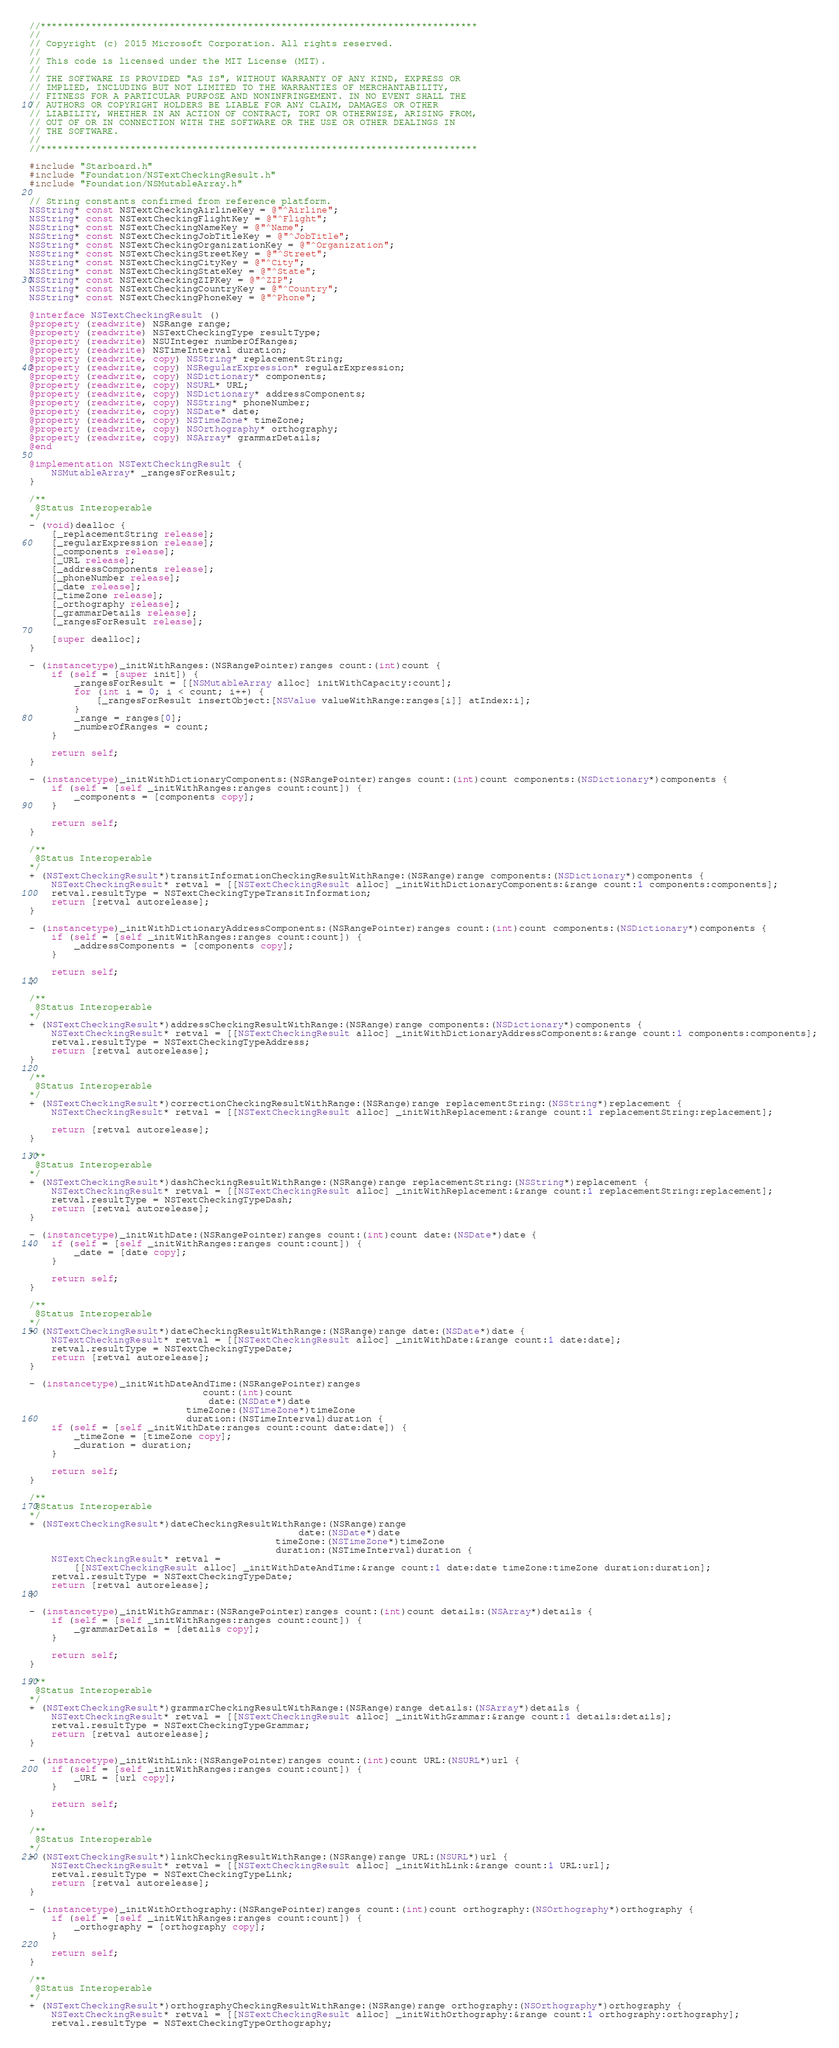<code> <loc_0><loc_0><loc_500><loc_500><_ObjectiveC_>//******************************************************************************
//
// Copyright (c) 2015 Microsoft Corporation. All rights reserved.
//
// This code is licensed under the MIT License (MIT).
//
// THE SOFTWARE IS PROVIDED "AS IS", WITHOUT WARRANTY OF ANY KIND, EXPRESS OR
// IMPLIED, INCLUDING BUT NOT LIMITED TO THE WARRANTIES OF MERCHANTABILITY,
// FITNESS FOR A PARTICULAR PURPOSE AND NONINFRINGEMENT. IN NO EVENT SHALL THE
// AUTHORS OR COPYRIGHT HOLDERS BE LIABLE FOR ANY CLAIM, DAMAGES OR OTHER
// LIABILITY, WHETHER IN AN ACTION OF CONTRACT, TORT OR OTHERWISE, ARISING FROM,
// OUT OF OR IN CONNECTION WITH THE SOFTWARE OR THE USE OR OTHER DEALINGS IN
// THE SOFTWARE.
//
//******************************************************************************

#include "Starboard.h"
#include "Foundation/NSTextCheckingResult.h"
#include "Foundation/NSMutableArray.h"

// String constants confirmed from reference platform.
NSString* const NSTextCheckingAirlineKey = @"^Airline";
NSString* const NSTextCheckingFlightKey = @"^Flight";
NSString* const NSTextCheckingNameKey = @"^Name";
NSString* const NSTextCheckingJobTitleKey = @"^JobTitle";
NSString* const NSTextCheckingOrganizationKey = @"^Organization";
NSString* const NSTextCheckingStreetKey = @"^Street";
NSString* const NSTextCheckingCityKey = @"^City";
NSString* const NSTextCheckingStateKey = @"^State";
NSString* const NSTextCheckingZIPKey = @"^ZIP";
NSString* const NSTextCheckingCountryKey = @"^Country";
NSString* const NSTextCheckingPhoneKey = @"^Phone";

@interface NSTextCheckingResult ()
@property (readwrite) NSRange range;
@property (readwrite) NSTextCheckingType resultType;
@property (readwrite) NSUInteger numberOfRanges;
@property (readwrite) NSTimeInterval duration;
@property (readwrite, copy) NSString* replacementString;
@property (readwrite, copy) NSRegularExpression* regularExpression;
@property (readwrite, copy) NSDictionary* components;
@property (readwrite, copy) NSURL* URL;
@property (readwrite, copy) NSDictionary* addressComponents;
@property (readwrite, copy) NSString* phoneNumber;
@property (readwrite, copy) NSDate* date;
@property (readwrite, copy) NSTimeZone* timeZone;
@property (readwrite, copy) NSOrthography* orthography;
@property (readwrite, copy) NSArray* grammarDetails;
@end

@implementation NSTextCheckingResult {
    NSMutableArray* _rangesForResult;
}

/**
 @Status Interoperable
*/
- (void)dealloc {
    [_replacementString release];
    [_regularExpression release];
    [_components release];
    [_URL release];
    [_addressComponents release];
    [_phoneNumber release];
    [_date release];
    [_timeZone release];
    [_orthography release];
    [_grammarDetails release];
    [_rangesForResult release];

    [super dealloc];
}

- (instancetype)_initWithRanges:(NSRangePointer)ranges count:(int)count {
    if (self = [super init]) {
        _rangesForResult = [[NSMutableArray alloc] initWithCapacity:count];
        for (int i = 0; i < count; i++) {
            [_rangesForResult insertObject:[NSValue valueWithRange:ranges[i]] atIndex:i];
        }
        _range = ranges[0];
        _numberOfRanges = count;
    }

    return self;
}

- (instancetype)_initWithDictionaryComponents:(NSRangePointer)ranges count:(int)count components:(NSDictionary*)components {
    if (self = [self _initWithRanges:ranges count:count]) {
        _components = [components copy];
    }

    return self;
}

/**
 @Status Interoperable
*/
+ (NSTextCheckingResult*)transitInformationCheckingResultWithRange:(NSRange)range components:(NSDictionary*)components {
    NSTextCheckingResult* retval = [[NSTextCheckingResult alloc] _initWithDictionaryComponents:&range count:1 components:components];
    retval.resultType = NSTextCheckingTypeTransitInformation;
    return [retval autorelease];
}

- (instancetype)_initWithDictionaryAddressComponents:(NSRangePointer)ranges count:(int)count components:(NSDictionary*)components {
    if (self = [self _initWithRanges:ranges count:count]) {
        _addressComponents = [components copy];
    }

    return self;
}

/**
 @Status Interoperable
*/
+ (NSTextCheckingResult*)addressCheckingResultWithRange:(NSRange)range components:(NSDictionary*)components {
    NSTextCheckingResult* retval = [[NSTextCheckingResult alloc] _initWithDictionaryAddressComponents:&range count:1 components:components];
    retval.resultType = NSTextCheckingTypeAddress;
    return [retval autorelease];
}

/**
 @Status Interoperable
*/
+ (NSTextCheckingResult*)correctionCheckingResultWithRange:(NSRange)range replacementString:(NSString*)replacement {
    NSTextCheckingResult* retval = [[NSTextCheckingResult alloc] _initWithReplacement:&range count:1 replacementString:replacement];

    return [retval autorelease];
}

/**
 @Status Interoperable
*/
+ (NSTextCheckingResult*)dashCheckingResultWithRange:(NSRange)range replacementString:(NSString*)replacement {
    NSTextCheckingResult* retval = [[NSTextCheckingResult alloc] _initWithReplacement:&range count:1 replacementString:replacement];
    retval.resultType = NSTextCheckingTypeDash;
    return [retval autorelease];
}

- (instancetype)_initWithDate:(NSRangePointer)ranges count:(int)count date:(NSDate*)date {
    if (self = [self _initWithRanges:ranges count:count]) {
        _date = [date copy];
    }

    return self;
}

/**
 @Status Interoperable
*/
+ (NSTextCheckingResult*)dateCheckingResultWithRange:(NSRange)range date:(NSDate*)date {
    NSTextCheckingResult* retval = [[NSTextCheckingResult alloc] _initWithDate:&range count:1 date:date];
    retval.resultType = NSTextCheckingTypeDate;
    return [retval autorelease];
}

- (instancetype)_initWithDateAndTime:(NSRangePointer)ranges
                               count:(int)count
                                date:(NSDate*)date
                            timeZone:(NSTimeZone*)timeZone
                            duration:(NSTimeInterval)duration {
    if (self = [self _initWithDate:ranges count:count date:date]) {
        _timeZone = [timeZone copy];
        _duration = duration;
    }

    return self;
}

/**
 @Status Interoperable
*/
+ (NSTextCheckingResult*)dateCheckingResultWithRange:(NSRange)range
                                                date:(NSDate*)date
                                            timeZone:(NSTimeZone*)timeZone
                                            duration:(NSTimeInterval)duration {
    NSTextCheckingResult* retval =
        [[NSTextCheckingResult alloc] _initWithDateAndTime:&range count:1 date:date timeZone:timeZone duration:duration];
    retval.resultType = NSTextCheckingTypeDate;
    return [retval autorelease];
}

- (instancetype)_initWithGrammar:(NSRangePointer)ranges count:(int)count details:(NSArray*)details {
    if (self = [self _initWithRanges:ranges count:count]) {
        _grammarDetails = [details copy];
    }

    return self;
}

/**
 @Status Interoperable
*/
+ (NSTextCheckingResult*)grammarCheckingResultWithRange:(NSRange)range details:(NSArray*)details {
    NSTextCheckingResult* retval = [[NSTextCheckingResult alloc] _initWithGrammar:&range count:1 details:details];
    retval.resultType = NSTextCheckingTypeGrammar;
    return [retval autorelease];
}

- (instancetype)_initWithLink:(NSRangePointer)ranges count:(int)count URL:(NSURL*)url {
    if (self = [self _initWithRanges:ranges count:count]) {
        _URL = [url copy];
    }

    return self;
}

/**
 @Status Interoperable
*/
+ (NSTextCheckingResult*)linkCheckingResultWithRange:(NSRange)range URL:(NSURL*)url {
    NSTextCheckingResult* retval = [[NSTextCheckingResult alloc] _initWithLink:&range count:1 URL:url];
    retval.resultType = NSTextCheckingTypeLink;
    return [retval autorelease];
}

- (instancetype)_initWithOrthography:(NSRangePointer)ranges count:(int)count orthography:(NSOrthography*)orthography {
    if (self = [self _initWithRanges:ranges count:count]) {
        _orthography = [orthography copy];
    }

    return self;
}

/**
 @Status Interoperable
*/
+ (NSTextCheckingResult*)orthographyCheckingResultWithRange:(NSRange)range orthography:(NSOrthography*)orthography {
    NSTextCheckingResult* retval = [[NSTextCheckingResult alloc] _initWithOrthography:&range count:1 orthography:orthography];
    retval.resultType = NSTextCheckingTypeOrthography;</code> 